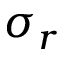Convert formula to latex. <formula><loc_0><loc_0><loc_500><loc_500>\sigma _ { r }</formula> 